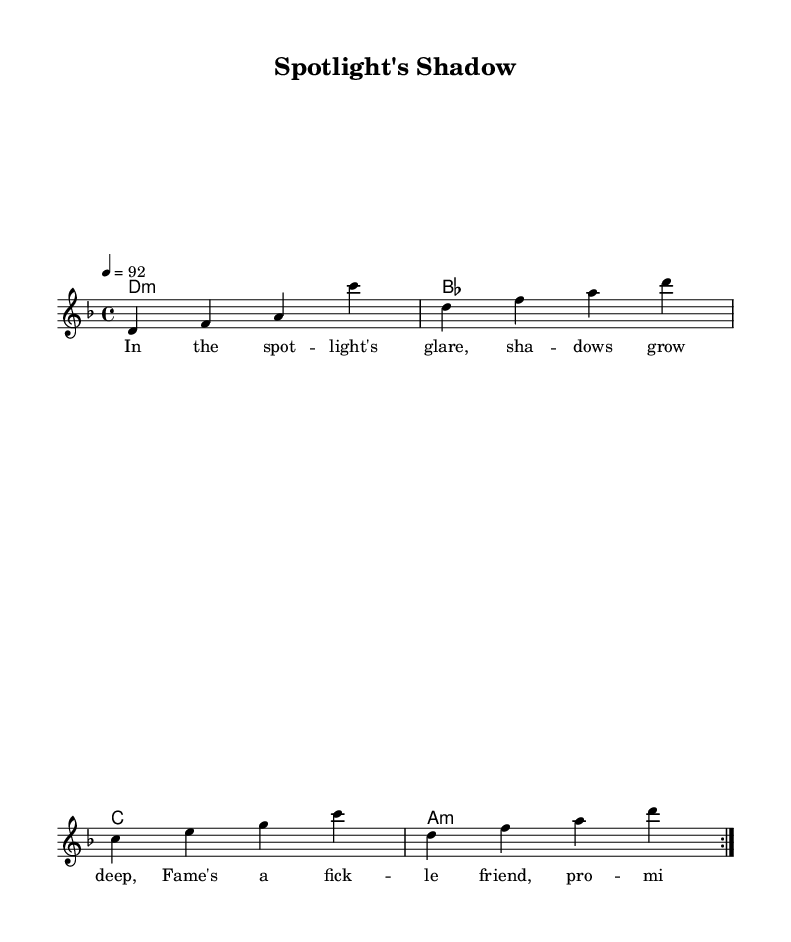What is the title of this piece? The title is indicated at the top of the sheet music, where it is prominently displayed.
Answer: Spotlight's Shadow What is the key signature of this music? The key signature is indicated by the presence of accidentals and notes in the harmonic section. In this sheet music, it is in D minor.
Answer: D minor What is the time signature of the piece? The time signature is displayed at the beginning of the music and shows how many beats are in each measure. This piece has a time signature of 4/4.
Answer: 4/4 What is the tempo marking of this piece? The tempo marking, which indicates the speed of the piece, is found near the top of the sheet music. It shows a metronomic marking of 92 beats per minute.
Answer: 92 How many times is the melody repeated in this section? The repeat indication suggests that the melody section should be played twice, as denoted by the "repeat volta 2."
Answer: 2 What type of chord progression is used in the harmonies? The chord mode section indicates the type of progression. Here, it includes a mix of minor and major chords, specifically D minor, B flat, C, and A minor.
Answer: Minor and Major What is the overall theme explored in the lyrics? The lyrics discuss challenges and triumphs in the entertainment industry, providing a reflection on fame and its complexities.
Answer: Entertainment industry 